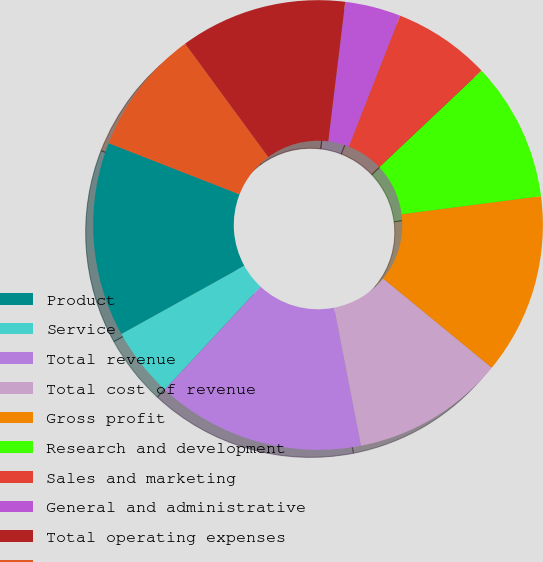Convert chart. <chart><loc_0><loc_0><loc_500><loc_500><pie_chart><fcel>Product<fcel>Service<fcel>Total revenue<fcel>Total cost of revenue<fcel>Gross profit<fcel>Research and development<fcel>Sales and marketing<fcel>General and administrative<fcel>Total operating expenses<fcel>Income from operations<nl><fcel>13.99%<fcel>5.01%<fcel>14.99%<fcel>11.0%<fcel>12.99%<fcel>10.0%<fcel>7.01%<fcel>4.01%<fcel>12.0%<fcel>9.0%<nl></chart> 